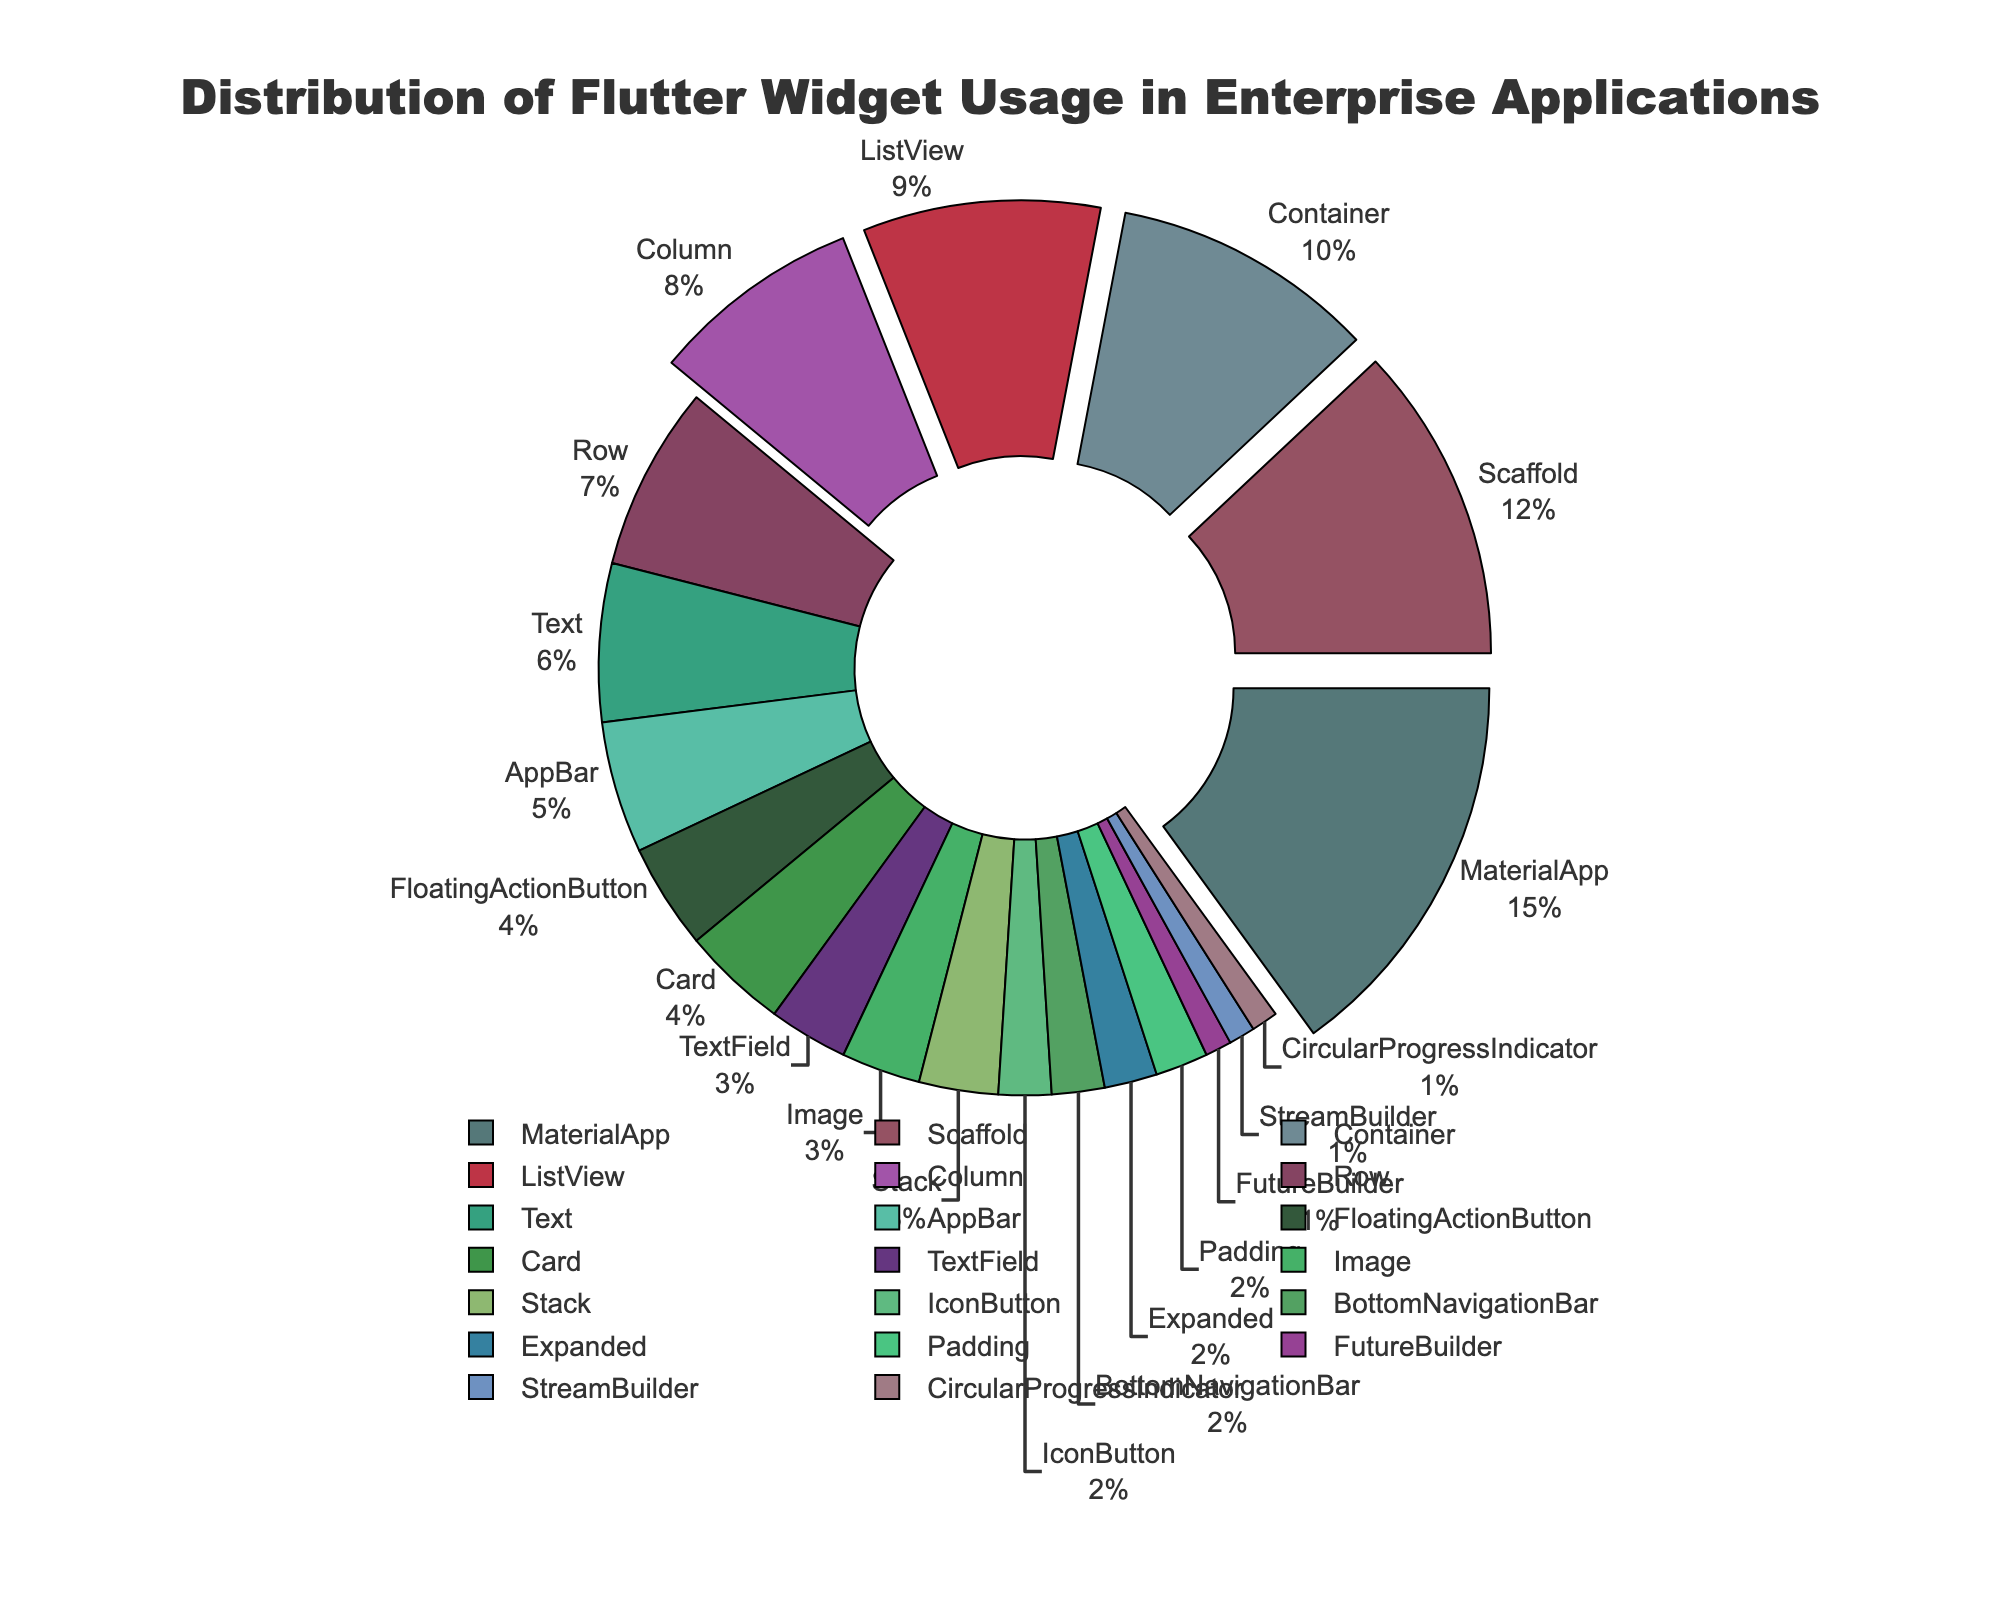What's the most used Flutter widget in enterprise applications? The figure shows that each widget is represented by a percentage of usage. The largest section of the pie chart corresponds to "MaterialApp" with a percentage of 15%.
Answer: MaterialApp Which widget has greater usage, Column or Row? By looking at the pie chart, the percentage next to Column is 8%, while the percentage next to Row is 7%. Since 8% is greater than 7%, Column has more usage.
Answer: Column What's the total percentage usage of Container and ListView combined? Container has a percentage of 10%, and ListView has 9%. Adding these together: 10% + 9% = 19%.
Answer: 19% Which 4 widgets have the largest usage percentages? The figure illustrates the sections with different sizes. The four largest sections correspond to "MaterialApp" (15%), "Scaffold" (12%), "Container" (10%), and "ListView" (9%) based on their percentage sizes in descending order.
Answer: MaterialApp, Scaffold, Container, ListView How does the usage of FloatingActionButton compare to that of Image? FloatingActionButton has a usage of 4%, and Image has a usage of 3%, as represented in their respective sections of the pie chart. Therefore, FloatingActionButton usage is higher than Image usage.
Answer: FloatingActionButton What's the combined total of all widgets with usage under 5%? The widgets under 5% are FloatingActionButton (4%), Card (4%), Image (3%), Stack (3%), TextField (3%), IconButton (2%), BottomNavigationBar (2%), Expanded (2%), Padding (2%), FutureBuilder (1%), StreamBuilder (1%), and CircularProgressIndicator (1%). Adding these percentages: 4% + 4% + 3% + 3% + 3% + 2% + 2% + 2% + 2% + 1% + 1% + 1% = 30%.
Answer: 30% Which widget has usage closest to 5%? By examining the percentages closest to 5%, "AppBar" has exactly 5%, making it the closest to the specified value.
Answer: AppBar What is the difference in usage percentage between the most and least used widget? The most-used widget is MaterialApp at 15%, and the least-used widgets are FutureBuilder, StreamBuilder, and CircularProgressIndicator, each at 1%. The difference between the two is 15% - 1% = 14%.
Answer: 14% How many widgets have a usage percentage of at least 8%? By looking at the pie chart, the widgets with at least 8% are MaterialApp (15%), Scaffold (12%), Container (10%), and ListView (9%), Column (8%)—a total of five widgets.
Answer: Five 